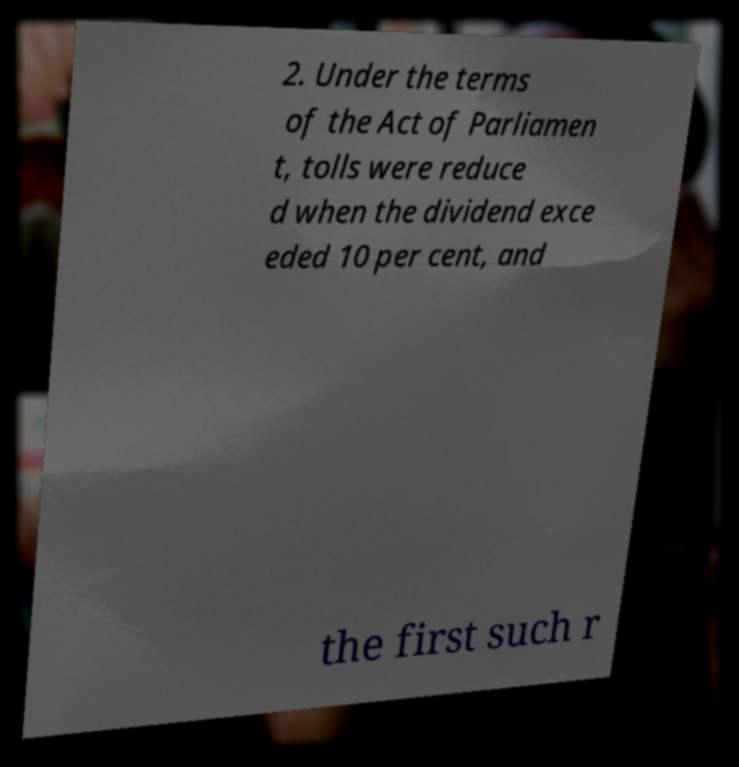Could you extract and type out the text from this image? 2. Under the terms of the Act of Parliamen t, tolls were reduce d when the dividend exce eded 10 per cent, and the first such r 